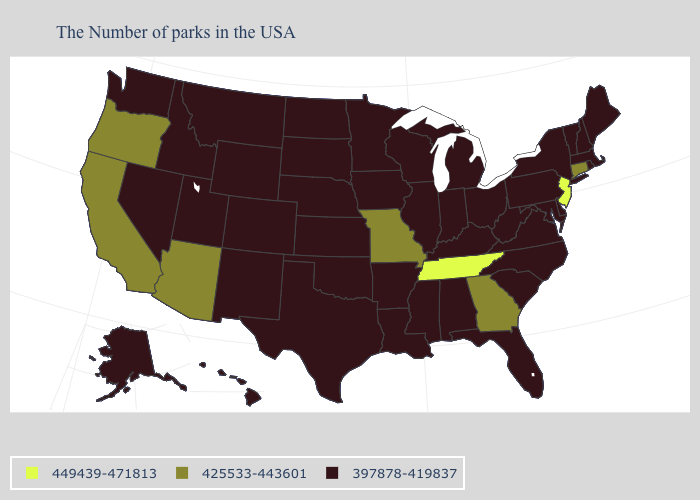Name the states that have a value in the range 397878-419837?
Concise answer only. Maine, Massachusetts, Rhode Island, New Hampshire, Vermont, New York, Delaware, Maryland, Pennsylvania, Virginia, North Carolina, South Carolina, West Virginia, Ohio, Florida, Michigan, Kentucky, Indiana, Alabama, Wisconsin, Illinois, Mississippi, Louisiana, Arkansas, Minnesota, Iowa, Kansas, Nebraska, Oklahoma, Texas, South Dakota, North Dakota, Wyoming, Colorado, New Mexico, Utah, Montana, Idaho, Nevada, Washington, Alaska, Hawaii. Name the states that have a value in the range 397878-419837?
Be succinct. Maine, Massachusetts, Rhode Island, New Hampshire, Vermont, New York, Delaware, Maryland, Pennsylvania, Virginia, North Carolina, South Carolina, West Virginia, Ohio, Florida, Michigan, Kentucky, Indiana, Alabama, Wisconsin, Illinois, Mississippi, Louisiana, Arkansas, Minnesota, Iowa, Kansas, Nebraska, Oklahoma, Texas, South Dakota, North Dakota, Wyoming, Colorado, New Mexico, Utah, Montana, Idaho, Nevada, Washington, Alaska, Hawaii. What is the highest value in the West ?
Short answer required. 425533-443601. What is the value of Nevada?
Concise answer only. 397878-419837. Among the states that border Nebraska , does Kansas have the lowest value?
Short answer required. Yes. What is the highest value in the USA?
Be succinct. 449439-471813. What is the value of Kentucky?
Quick response, please. 397878-419837. Which states have the lowest value in the USA?
Quick response, please. Maine, Massachusetts, Rhode Island, New Hampshire, Vermont, New York, Delaware, Maryland, Pennsylvania, Virginia, North Carolina, South Carolina, West Virginia, Ohio, Florida, Michigan, Kentucky, Indiana, Alabama, Wisconsin, Illinois, Mississippi, Louisiana, Arkansas, Minnesota, Iowa, Kansas, Nebraska, Oklahoma, Texas, South Dakota, North Dakota, Wyoming, Colorado, New Mexico, Utah, Montana, Idaho, Nevada, Washington, Alaska, Hawaii. What is the value of Idaho?
Quick response, please. 397878-419837. Does Minnesota have the lowest value in the USA?
Answer briefly. Yes. What is the value of New Hampshire?
Quick response, please. 397878-419837. What is the value of Arkansas?
Concise answer only. 397878-419837. Is the legend a continuous bar?
Answer briefly. No. What is the value of Virginia?
Quick response, please. 397878-419837. Among the states that border Kentucky , which have the lowest value?
Concise answer only. Virginia, West Virginia, Ohio, Indiana, Illinois. 